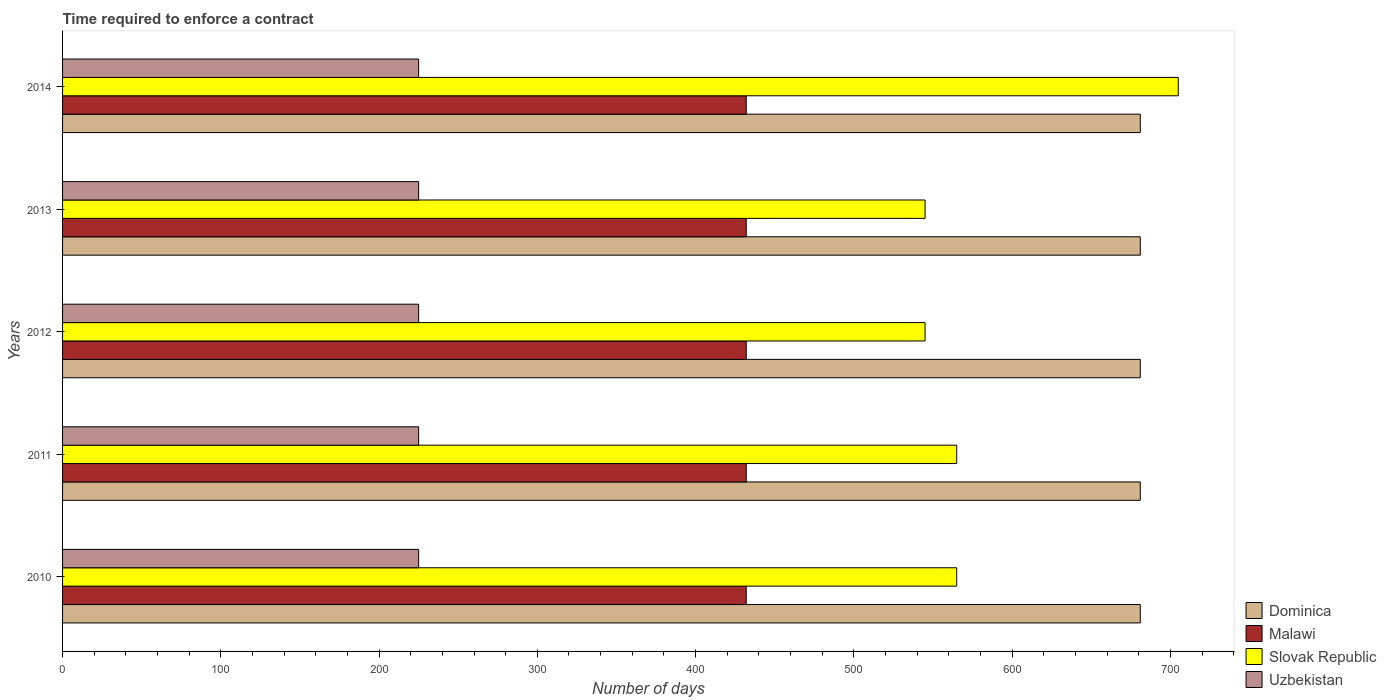How many different coloured bars are there?
Your response must be concise. 4. How many groups of bars are there?
Provide a short and direct response. 5. Are the number of bars on each tick of the Y-axis equal?
Offer a terse response. Yes. What is the label of the 3rd group of bars from the top?
Offer a terse response. 2012. In how many cases, is the number of bars for a given year not equal to the number of legend labels?
Ensure brevity in your answer.  0. What is the number of days required to enforce a contract in Uzbekistan in 2011?
Your response must be concise. 225. Across all years, what is the maximum number of days required to enforce a contract in Dominica?
Offer a very short reply. 681. Across all years, what is the minimum number of days required to enforce a contract in Uzbekistan?
Offer a very short reply. 225. What is the total number of days required to enforce a contract in Slovak Republic in the graph?
Your answer should be very brief. 2925. What is the difference between the number of days required to enforce a contract in Uzbekistan in 2010 and that in 2013?
Give a very brief answer. 0. What is the difference between the number of days required to enforce a contract in Uzbekistan in 2014 and the number of days required to enforce a contract in Slovak Republic in 2012?
Offer a very short reply. -320. What is the average number of days required to enforce a contract in Slovak Republic per year?
Offer a very short reply. 585. In the year 2013, what is the difference between the number of days required to enforce a contract in Malawi and number of days required to enforce a contract in Uzbekistan?
Ensure brevity in your answer.  207. In how many years, is the number of days required to enforce a contract in Uzbekistan greater than 460 days?
Your response must be concise. 0. What is the difference between the highest and the second highest number of days required to enforce a contract in Malawi?
Provide a short and direct response. 0. In how many years, is the number of days required to enforce a contract in Dominica greater than the average number of days required to enforce a contract in Dominica taken over all years?
Make the answer very short. 0. Is the sum of the number of days required to enforce a contract in Uzbekistan in 2012 and 2013 greater than the maximum number of days required to enforce a contract in Slovak Republic across all years?
Give a very brief answer. No. Is it the case that in every year, the sum of the number of days required to enforce a contract in Uzbekistan and number of days required to enforce a contract in Malawi is greater than the sum of number of days required to enforce a contract in Dominica and number of days required to enforce a contract in Slovak Republic?
Keep it short and to the point. Yes. What does the 2nd bar from the top in 2013 represents?
Your response must be concise. Slovak Republic. What does the 2nd bar from the bottom in 2013 represents?
Your response must be concise. Malawi. Is it the case that in every year, the sum of the number of days required to enforce a contract in Dominica and number of days required to enforce a contract in Slovak Republic is greater than the number of days required to enforce a contract in Malawi?
Offer a very short reply. Yes. How many bars are there?
Your answer should be very brief. 20. Are all the bars in the graph horizontal?
Offer a very short reply. Yes. What is the difference between two consecutive major ticks on the X-axis?
Offer a very short reply. 100. Does the graph contain any zero values?
Provide a succinct answer. No. What is the title of the graph?
Offer a terse response. Time required to enforce a contract. Does "Tunisia" appear as one of the legend labels in the graph?
Give a very brief answer. No. What is the label or title of the X-axis?
Your response must be concise. Number of days. What is the label or title of the Y-axis?
Provide a succinct answer. Years. What is the Number of days in Dominica in 2010?
Provide a short and direct response. 681. What is the Number of days of Malawi in 2010?
Offer a terse response. 432. What is the Number of days of Slovak Republic in 2010?
Offer a very short reply. 565. What is the Number of days in Uzbekistan in 2010?
Offer a very short reply. 225. What is the Number of days of Dominica in 2011?
Your response must be concise. 681. What is the Number of days in Malawi in 2011?
Provide a short and direct response. 432. What is the Number of days in Slovak Republic in 2011?
Keep it short and to the point. 565. What is the Number of days in Uzbekistan in 2011?
Your response must be concise. 225. What is the Number of days of Dominica in 2012?
Offer a very short reply. 681. What is the Number of days of Malawi in 2012?
Your response must be concise. 432. What is the Number of days of Slovak Republic in 2012?
Make the answer very short. 545. What is the Number of days of Uzbekistan in 2012?
Your response must be concise. 225. What is the Number of days in Dominica in 2013?
Offer a terse response. 681. What is the Number of days of Malawi in 2013?
Provide a short and direct response. 432. What is the Number of days of Slovak Republic in 2013?
Provide a short and direct response. 545. What is the Number of days of Uzbekistan in 2013?
Offer a terse response. 225. What is the Number of days in Dominica in 2014?
Offer a very short reply. 681. What is the Number of days in Malawi in 2014?
Offer a terse response. 432. What is the Number of days in Slovak Republic in 2014?
Your answer should be compact. 705. What is the Number of days of Uzbekistan in 2014?
Provide a short and direct response. 225. Across all years, what is the maximum Number of days of Dominica?
Your answer should be very brief. 681. Across all years, what is the maximum Number of days in Malawi?
Make the answer very short. 432. Across all years, what is the maximum Number of days in Slovak Republic?
Ensure brevity in your answer.  705. Across all years, what is the maximum Number of days in Uzbekistan?
Make the answer very short. 225. Across all years, what is the minimum Number of days in Dominica?
Your response must be concise. 681. Across all years, what is the minimum Number of days in Malawi?
Offer a very short reply. 432. Across all years, what is the minimum Number of days in Slovak Republic?
Ensure brevity in your answer.  545. Across all years, what is the minimum Number of days in Uzbekistan?
Your response must be concise. 225. What is the total Number of days in Dominica in the graph?
Your response must be concise. 3405. What is the total Number of days in Malawi in the graph?
Provide a succinct answer. 2160. What is the total Number of days of Slovak Republic in the graph?
Ensure brevity in your answer.  2925. What is the total Number of days of Uzbekistan in the graph?
Give a very brief answer. 1125. What is the difference between the Number of days in Dominica in 2010 and that in 2011?
Offer a very short reply. 0. What is the difference between the Number of days of Uzbekistan in 2010 and that in 2011?
Offer a very short reply. 0. What is the difference between the Number of days of Dominica in 2010 and that in 2012?
Provide a succinct answer. 0. What is the difference between the Number of days of Slovak Republic in 2010 and that in 2012?
Your answer should be compact. 20. What is the difference between the Number of days in Dominica in 2010 and that in 2013?
Provide a succinct answer. 0. What is the difference between the Number of days of Slovak Republic in 2010 and that in 2013?
Make the answer very short. 20. What is the difference between the Number of days of Uzbekistan in 2010 and that in 2013?
Your response must be concise. 0. What is the difference between the Number of days in Malawi in 2010 and that in 2014?
Your response must be concise. 0. What is the difference between the Number of days in Slovak Republic in 2010 and that in 2014?
Ensure brevity in your answer.  -140. What is the difference between the Number of days in Uzbekistan in 2010 and that in 2014?
Make the answer very short. 0. What is the difference between the Number of days of Slovak Republic in 2011 and that in 2012?
Offer a very short reply. 20. What is the difference between the Number of days of Malawi in 2011 and that in 2013?
Offer a terse response. 0. What is the difference between the Number of days of Slovak Republic in 2011 and that in 2013?
Offer a terse response. 20. What is the difference between the Number of days in Slovak Republic in 2011 and that in 2014?
Your answer should be compact. -140. What is the difference between the Number of days of Dominica in 2012 and that in 2013?
Offer a very short reply. 0. What is the difference between the Number of days in Malawi in 2012 and that in 2013?
Offer a terse response. 0. What is the difference between the Number of days of Slovak Republic in 2012 and that in 2013?
Your answer should be very brief. 0. What is the difference between the Number of days in Uzbekistan in 2012 and that in 2013?
Offer a terse response. 0. What is the difference between the Number of days of Malawi in 2012 and that in 2014?
Your answer should be compact. 0. What is the difference between the Number of days of Slovak Republic in 2012 and that in 2014?
Your answer should be very brief. -160. What is the difference between the Number of days of Uzbekistan in 2012 and that in 2014?
Offer a terse response. 0. What is the difference between the Number of days of Dominica in 2013 and that in 2014?
Your answer should be very brief. 0. What is the difference between the Number of days of Slovak Republic in 2013 and that in 2014?
Keep it short and to the point. -160. What is the difference between the Number of days in Dominica in 2010 and the Number of days in Malawi in 2011?
Your response must be concise. 249. What is the difference between the Number of days in Dominica in 2010 and the Number of days in Slovak Republic in 2011?
Provide a short and direct response. 116. What is the difference between the Number of days in Dominica in 2010 and the Number of days in Uzbekistan in 2011?
Your answer should be compact. 456. What is the difference between the Number of days of Malawi in 2010 and the Number of days of Slovak Republic in 2011?
Ensure brevity in your answer.  -133. What is the difference between the Number of days in Malawi in 2010 and the Number of days in Uzbekistan in 2011?
Make the answer very short. 207. What is the difference between the Number of days in Slovak Republic in 2010 and the Number of days in Uzbekistan in 2011?
Your response must be concise. 340. What is the difference between the Number of days in Dominica in 2010 and the Number of days in Malawi in 2012?
Offer a terse response. 249. What is the difference between the Number of days in Dominica in 2010 and the Number of days in Slovak Republic in 2012?
Keep it short and to the point. 136. What is the difference between the Number of days of Dominica in 2010 and the Number of days of Uzbekistan in 2012?
Offer a terse response. 456. What is the difference between the Number of days of Malawi in 2010 and the Number of days of Slovak Republic in 2012?
Your answer should be compact. -113. What is the difference between the Number of days in Malawi in 2010 and the Number of days in Uzbekistan in 2012?
Your response must be concise. 207. What is the difference between the Number of days in Slovak Republic in 2010 and the Number of days in Uzbekistan in 2012?
Ensure brevity in your answer.  340. What is the difference between the Number of days of Dominica in 2010 and the Number of days of Malawi in 2013?
Offer a very short reply. 249. What is the difference between the Number of days in Dominica in 2010 and the Number of days in Slovak Republic in 2013?
Ensure brevity in your answer.  136. What is the difference between the Number of days in Dominica in 2010 and the Number of days in Uzbekistan in 2013?
Provide a succinct answer. 456. What is the difference between the Number of days in Malawi in 2010 and the Number of days in Slovak Republic in 2013?
Ensure brevity in your answer.  -113. What is the difference between the Number of days in Malawi in 2010 and the Number of days in Uzbekistan in 2013?
Provide a succinct answer. 207. What is the difference between the Number of days of Slovak Republic in 2010 and the Number of days of Uzbekistan in 2013?
Your response must be concise. 340. What is the difference between the Number of days of Dominica in 2010 and the Number of days of Malawi in 2014?
Provide a short and direct response. 249. What is the difference between the Number of days in Dominica in 2010 and the Number of days in Slovak Republic in 2014?
Your answer should be compact. -24. What is the difference between the Number of days in Dominica in 2010 and the Number of days in Uzbekistan in 2014?
Offer a very short reply. 456. What is the difference between the Number of days in Malawi in 2010 and the Number of days in Slovak Republic in 2014?
Give a very brief answer. -273. What is the difference between the Number of days of Malawi in 2010 and the Number of days of Uzbekistan in 2014?
Your answer should be very brief. 207. What is the difference between the Number of days of Slovak Republic in 2010 and the Number of days of Uzbekistan in 2014?
Provide a short and direct response. 340. What is the difference between the Number of days in Dominica in 2011 and the Number of days in Malawi in 2012?
Give a very brief answer. 249. What is the difference between the Number of days in Dominica in 2011 and the Number of days in Slovak Republic in 2012?
Make the answer very short. 136. What is the difference between the Number of days of Dominica in 2011 and the Number of days of Uzbekistan in 2012?
Provide a short and direct response. 456. What is the difference between the Number of days of Malawi in 2011 and the Number of days of Slovak Republic in 2012?
Ensure brevity in your answer.  -113. What is the difference between the Number of days in Malawi in 2011 and the Number of days in Uzbekistan in 2012?
Offer a terse response. 207. What is the difference between the Number of days of Slovak Republic in 2011 and the Number of days of Uzbekistan in 2012?
Provide a succinct answer. 340. What is the difference between the Number of days in Dominica in 2011 and the Number of days in Malawi in 2013?
Your answer should be compact. 249. What is the difference between the Number of days in Dominica in 2011 and the Number of days in Slovak Republic in 2013?
Your answer should be compact. 136. What is the difference between the Number of days in Dominica in 2011 and the Number of days in Uzbekistan in 2013?
Ensure brevity in your answer.  456. What is the difference between the Number of days of Malawi in 2011 and the Number of days of Slovak Republic in 2013?
Keep it short and to the point. -113. What is the difference between the Number of days of Malawi in 2011 and the Number of days of Uzbekistan in 2013?
Offer a very short reply. 207. What is the difference between the Number of days in Slovak Republic in 2011 and the Number of days in Uzbekistan in 2013?
Provide a succinct answer. 340. What is the difference between the Number of days in Dominica in 2011 and the Number of days in Malawi in 2014?
Your answer should be very brief. 249. What is the difference between the Number of days in Dominica in 2011 and the Number of days in Slovak Republic in 2014?
Keep it short and to the point. -24. What is the difference between the Number of days in Dominica in 2011 and the Number of days in Uzbekistan in 2014?
Your response must be concise. 456. What is the difference between the Number of days of Malawi in 2011 and the Number of days of Slovak Republic in 2014?
Ensure brevity in your answer.  -273. What is the difference between the Number of days in Malawi in 2011 and the Number of days in Uzbekistan in 2014?
Your answer should be very brief. 207. What is the difference between the Number of days of Slovak Republic in 2011 and the Number of days of Uzbekistan in 2014?
Offer a terse response. 340. What is the difference between the Number of days of Dominica in 2012 and the Number of days of Malawi in 2013?
Your response must be concise. 249. What is the difference between the Number of days in Dominica in 2012 and the Number of days in Slovak Republic in 2013?
Offer a terse response. 136. What is the difference between the Number of days of Dominica in 2012 and the Number of days of Uzbekistan in 2013?
Your response must be concise. 456. What is the difference between the Number of days of Malawi in 2012 and the Number of days of Slovak Republic in 2013?
Your answer should be compact. -113. What is the difference between the Number of days of Malawi in 2012 and the Number of days of Uzbekistan in 2013?
Provide a succinct answer. 207. What is the difference between the Number of days of Slovak Republic in 2012 and the Number of days of Uzbekistan in 2013?
Offer a very short reply. 320. What is the difference between the Number of days of Dominica in 2012 and the Number of days of Malawi in 2014?
Your answer should be compact. 249. What is the difference between the Number of days in Dominica in 2012 and the Number of days in Slovak Republic in 2014?
Make the answer very short. -24. What is the difference between the Number of days of Dominica in 2012 and the Number of days of Uzbekistan in 2014?
Make the answer very short. 456. What is the difference between the Number of days of Malawi in 2012 and the Number of days of Slovak Republic in 2014?
Ensure brevity in your answer.  -273. What is the difference between the Number of days in Malawi in 2012 and the Number of days in Uzbekistan in 2014?
Your response must be concise. 207. What is the difference between the Number of days in Slovak Republic in 2012 and the Number of days in Uzbekistan in 2014?
Provide a short and direct response. 320. What is the difference between the Number of days of Dominica in 2013 and the Number of days of Malawi in 2014?
Keep it short and to the point. 249. What is the difference between the Number of days of Dominica in 2013 and the Number of days of Slovak Republic in 2014?
Your answer should be very brief. -24. What is the difference between the Number of days of Dominica in 2013 and the Number of days of Uzbekistan in 2014?
Make the answer very short. 456. What is the difference between the Number of days in Malawi in 2013 and the Number of days in Slovak Republic in 2014?
Give a very brief answer. -273. What is the difference between the Number of days of Malawi in 2013 and the Number of days of Uzbekistan in 2014?
Provide a short and direct response. 207. What is the difference between the Number of days of Slovak Republic in 2013 and the Number of days of Uzbekistan in 2014?
Ensure brevity in your answer.  320. What is the average Number of days of Dominica per year?
Your response must be concise. 681. What is the average Number of days in Malawi per year?
Provide a succinct answer. 432. What is the average Number of days in Slovak Republic per year?
Provide a short and direct response. 585. What is the average Number of days in Uzbekistan per year?
Ensure brevity in your answer.  225. In the year 2010, what is the difference between the Number of days of Dominica and Number of days of Malawi?
Make the answer very short. 249. In the year 2010, what is the difference between the Number of days of Dominica and Number of days of Slovak Republic?
Ensure brevity in your answer.  116. In the year 2010, what is the difference between the Number of days of Dominica and Number of days of Uzbekistan?
Keep it short and to the point. 456. In the year 2010, what is the difference between the Number of days in Malawi and Number of days in Slovak Republic?
Your response must be concise. -133. In the year 2010, what is the difference between the Number of days of Malawi and Number of days of Uzbekistan?
Offer a terse response. 207. In the year 2010, what is the difference between the Number of days of Slovak Republic and Number of days of Uzbekistan?
Make the answer very short. 340. In the year 2011, what is the difference between the Number of days of Dominica and Number of days of Malawi?
Offer a terse response. 249. In the year 2011, what is the difference between the Number of days of Dominica and Number of days of Slovak Republic?
Ensure brevity in your answer.  116. In the year 2011, what is the difference between the Number of days in Dominica and Number of days in Uzbekistan?
Offer a terse response. 456. In the year 2011, what is the difference between the Number of days of Malawi and Number of days of Slovak Republic?
Provide a succinct answer. -133. In the year 2011, what is the difference between the Number of days in Malawi and Number of days in Uzbekistan?
Make the answer very short. 207. In the year 2011, what is the difference between the Number of days of Slovak Republic and Number of days of Uzbekistan?
Make the answer very short. 340. In the year 2012, what is the difference between the Number of days in Dominica and Number of days in Malawi?
Your answer should be compact. 249. In the year 2012, what is the difference between the Number of days in Dominica and Number of days in Slovak Republic?
Your response must be concise. 136. In the year 2012, what is the difference between the Number of days in Dominica and Number of days in Uzbekistan?
Your response must be concise. 456. In the year 2012, what is the difference between the Number of days in Malawi and Number of days in Slovak Republic?
Make the answer very short. -113. In the year 2012, what is the difference between the Number of days in Malawi and Number of days in Uzbekistan?
Your response must be concise. 207. In the year 2012, what is the difference between the Number of days in Slovak Republic and Number of days in Uzbekistan?
Your response must be concise. 320. In the year 2013, what is the difference between the Number of days in Dominica and Number of days in Malawi?
Your answer should be compact. 249. In the year 2013, what is the difference between the Number of days in Dominica and Number of days in Slovak Republic?
Your response must be concise. 136. In the year 2013, what is the difference between the Number of days of Dominica and Number of days of Uzbekistan?
Provide a succinct answer. 456. In the year 2013, what is the difference between the Number of days in Malawi and Number of days in Slovak Republic?
Offer a very short reply. -113. In the year 2013, what is the difference between the Number of days in Malawi and Number of days in Uzbekistan?
Provide a succinct answer. 207. In the year 2013, what is the difference between the Number of days in Slovak Republic and Number of days in Uzbekistan?
Provide a short and direct response. 320. In the year 2014, what is the difference between the Number of days of Dominica and Number of days of Malawi?
Offer a very short reply. 249. In the year 2014, what is the difference between the Number of days in Dominica and Number of days in Slovak Republic?
Provide a succinct answer. -24. In the year 2014, what is the difference between the Number of days in Dominica and Number of days in Uzbekistan?
Offer a terse response. 456. In the year 2014, what is the difference between the Number of days in Malawi and Number of days in Slovak Republic?
Your answer should be compact. -273. In the year 2014, what is the difference between the Number of days in Malawi and Number of days in Uzbekistan?
Your answer should be very brief. 207. In the year 2014, what is the difference between the Number of days in Slovak Republic and Number of days in Uzbekistan?
Your response must be concise. 480. What is the ratio of the Number of days in Dominica in 2010 to that in 2011?
Offer a very short reply. 1. What is the ratio of the Number of days of Slovak Republic in 2010 to that in 2011?
Ensure brevity in your answer.  1. What is the ratio of the Number of days of Slovak Republic in 2010 to that in 2012?
Give a very brief answer. 1.04. What is the ratio of the Number of days of Dominica in 2010 to that in 2013?
Provide a succinct answer. 1. What is the ratio of the Number of days of Malawi in 2010 to that in 2013?
Ensure brevity in your answer.  1. What is the ratio of the Number of days of Slovak Republic in 2010 to that in 2013?
Ensure brevity in your answer.  1.04. What is the ratio of the Number of days of Malawi in 2010 to that in 2014?
Ensure brevity in your answer.  1. What is the ratio of the Number of days in Slovak Republic in 2010 to that in 2014?
Ensure brevity in your answer.  0.8. What is the ratio of the Number of days of Uzbekistan in 2010 to that in 2014?
Make the answer very short. 1. What is the ratio of the Number of days of Slovak Republic in 2011 to that in 2012?
Your response must be concise. 1.04. What is the ratio of the Number of days of Slovak Republic in 2011 to that in 2013?
Ensure brevity in your answer.  1.04. What is the ratio of the Number of days of Dominica in 2011 to that in 2014?
Your response must be concise. 1. What is the ratio of the Number of days in Slovak Republic in 2011 to that in 2014?
Offer a very short reply. 0.8. What is the ratio of the Number of days of Dominica in 2012 to that in 2013?
Keep it short and to the point. 1. What is the ratio of the Number of days in Slovak Republic in 2012 to that in 2013?
Your answer should be compact. 1. What is the ratio of the Number of days of Dominica in 2012 to that in 2014?
Make the answer very short. 1. What is the ratio of the Number of days in Malawi in 2012 to that in 2014?
Give a very brief answer. 1. What is the ratio of the Number of days in Slovak Republic in 2012 to that in 2014?
Provide a short and direct response. 0.77. What is the ratio of the Number of days of Uzbekistan in 2012 to that in 2014?
Provide a short and direct response. 1. What is the ratio of the Number of days in Slovak Republic in 2013 to that in 2014?
Your response must be concise. 0.77. What is the difference between the highest and the second highest Number of days of Dominica?
Give a very brief answer. 0. What is the difference between the highest and the second highest Number of days in Malawi?
Provide a short and direct response. 0. What is the difference between the highest and the second highest Number of days of Slovak Republic?
Offer a very short reply. 140. What is the difference between the highest and the second highest Number of days of Uzbekistan?
Keep it short and to the point. 0. What is the difference between the highest and the lowest Number of days in Dominica?
Offer a very short reply. 0. What is the difference between the highest and the lowest Number of days of Malawi?
Keep it short and to the point. 0. What is the difference between the highest and the lowest Number of days in Slovak Republic?
Your response must be concise. 160. 